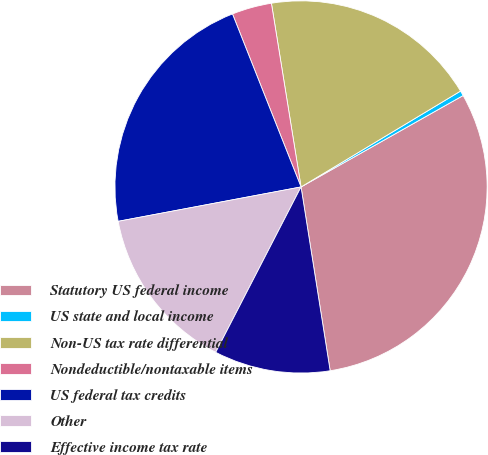<chart> <loc_0><loc_0><loc_500><loc_500><pie_chart><fcel>Statutory US federal income<fcel>US state and local income<fcel>Non-US tax rate differential<fcel>Nondeductible/nontaxable items<fcel>US federal tax credits<fcel>Other<fcel>Effective income tax rate<nl><fcel>30.67%<fcel>0.44%<fcel>18.93%<fcel>3.46%<fcel>21.95%<fcel>14.46%<fcel>10.08%<nl></chart> 